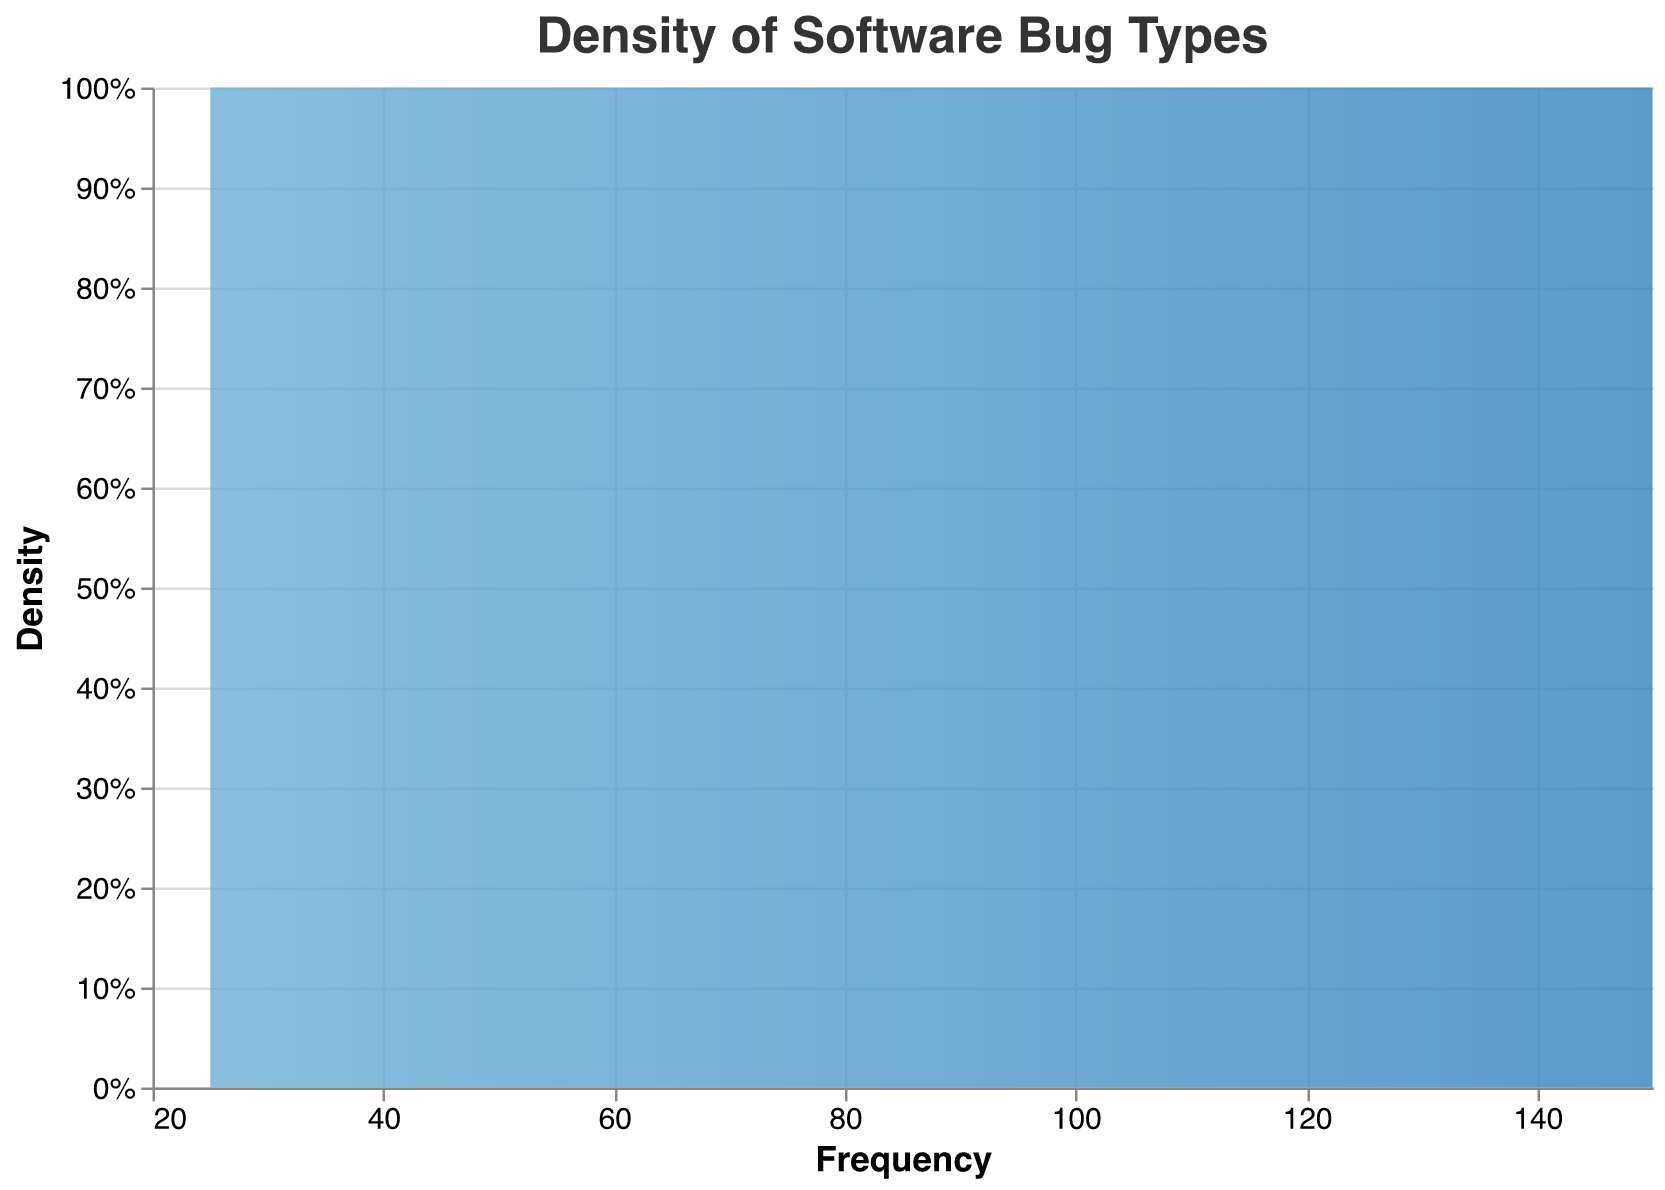What is the title of the figure? The title is usually found at the top of the figure. Here it states, "Density of Software Bug Types"
Answer: Density of Software Bug Types What is the total number of bug types represented in the plot? By counting the number of unique bug types listed under the "Bug_Type" category, we find there are 11 unique bug types.
Answer: 11 Which bug type has the highest frequency? By examining the frequencies, we find that "NullPointerException" has the highest frequency of 150.
Answer: NullPointerException Which bug type has the lowest frequency? By checking the frequencies, we find that "StackOverflowError" has the lowest frequency of 25.
Answer: StackOverflowError What is the frequency of 'ArrayIndexOutOfBoundsException'? The frequency can be directly observed from the plot, which shows 'ArrayIndexOutOfBoundsException' has a frequency of 120.
Answer: 120 What is the combined frequency of 'IOException' and 'FileNotFoundException'? By adding the frequencies of 'IOException' (90) and 'FileNotFoundException' (60), we get a combined frequency of 150.
Answer: 150 Which bug has a frequency equal to or less than 50? Bugs with frequencies equal to or less than 50 are 'NetworkOnMainThreadException' (40), 'ConcurrentModificationException' (45), 'ArithmeticException' (55), 'OutOfMemoryError' (30), and 'StackOverflowError' (25).
Answer: NetworkOnMainThreadException, ConcurrentModificationException, OutOfMemoryError, StackOverflowError What is the frequency difference between 'ClassNotFoundException' and 'IllegalArgumentException'? Subtract the frequency of 'ClassNotFoundException' (75) from 'IllegalArgumentException' (130), resulting in a difference of 55.
Answer: 55 Are there more than three types of bugs with a frequency greater than 100? By counting the bug types with frequencies greater than 100, which are 'NullPointerException' (150), 'ArrayIndexOutOfBoundsException' (120), and 'IllegalArgumentException' (130), there are exactly three.
Answer: No What is the range of the frequencies in the plot? The range is found by subtracting the minimum frequency (StackOverflowError, 25) from the maximum frequency (NullPointerException, 150), which gives a range of 125.
Answer: 125 